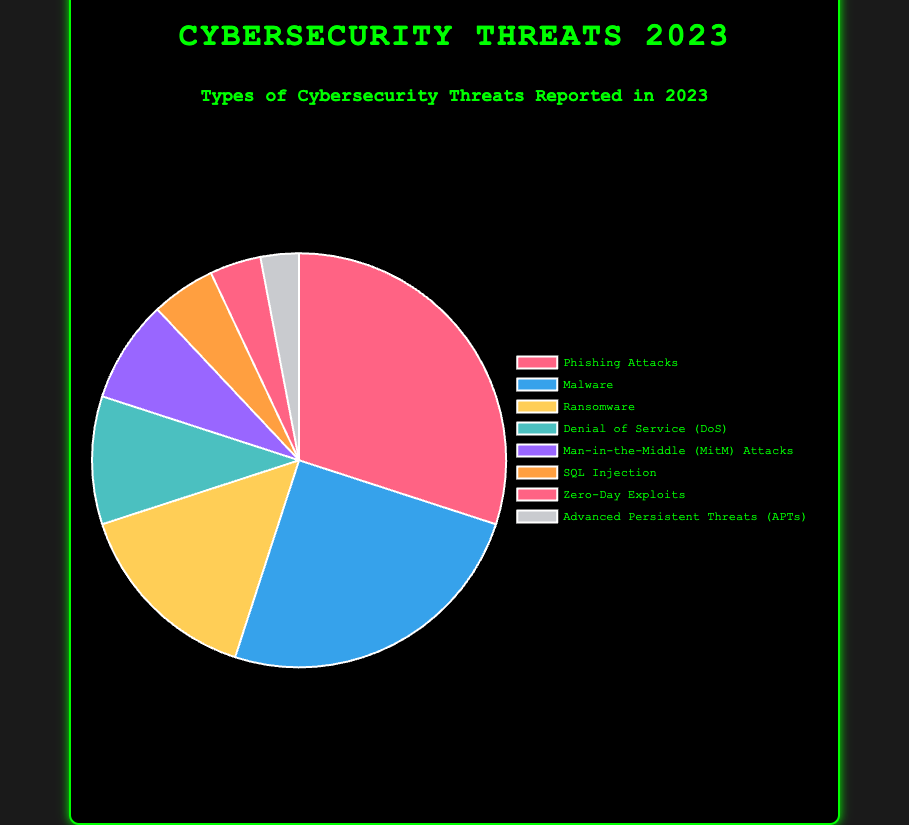Which type of cybersecurity threat is most reported in 2023? By looking at the pie chart, we see that the Phishing Attacks segment is the largest. Therefore, Phishing Attacks is the most reported type.
Answer: Phishing Attacks What percentage of reported cybersecurity threats is due to Malware? From the pie chart, we identify that the segment for Malware consists of 25%.
Answer: 25% Is the number of Ransomware incidents more than Denial of Service (DoS) incidents? In the pie chart, Ransomware's segment is 15%, while DoS's segment is 10%. Since 15% is greater than 10%, the answer is yes.
Answer: Yes How many more incidents of Phishing Attacks are there compared to Zero-Day Exploits? Phishing Attacks account for 30 incidents, and Zero-Day Exploits account for 4 incidents. The difference is 30 - 4 = 26.
Answer: 26 What is the total percentage of reported incidents for Man-in-the-Middle (MitM) Attacks and SQL Injection combined? MitM Attacks account for 8%, and SQL Injection accounts for 5%. Adding these together gives 8% + 5% = 13%.
Answer: 13% What percentage of reported threats is due to Advanced Persistent Threats (APTs)? The corresponding segment in the pie chart for APTs is labeled 3%.
Answer: 3% Which threats together constitute a larger percentage: DoS and MitM Attacks, or Ransomware alone? DoS is 10% and MitM Attacks is 8%, so together they form 10% + 8% = 18%. Ransomware is 15%. Since 18% > 15%, DoS and MitM Attacks together constitute a larger percentage.
Answer: DoS and MitM Attacks How many unique colors are used to represent the different threat types in the pie chart? By counting the distinct colors in the pie chart, we see that there are 8 unique colors, one for each type of threat.
Answer: 8 What is the least reported type of cybersecurity threat? From the pie chart, we identify the smallest segment which is Advanced Persistent Threats (APTs) with 3%.
Answer: Advanced Persistent Threats (APTs) If we combine the percentage of Malware and Phishing Attacks, what is the combined total? Malware accounts for 25%, and Phishing Attacks account for 30%. Adding these together gives 25% + 30% = 55%.
Answer: 55% 